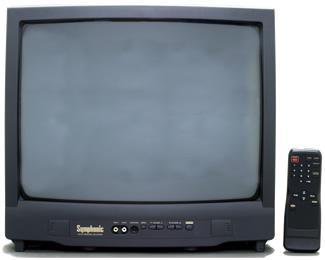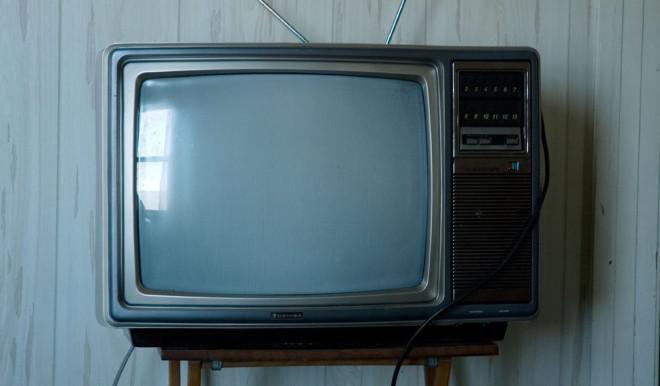The first image is the image on the left, the second image is the image on the right. For the images shown, is this caption "At least one of the images shows a remote next to the TV." true? Answer yes or no. Yes. 